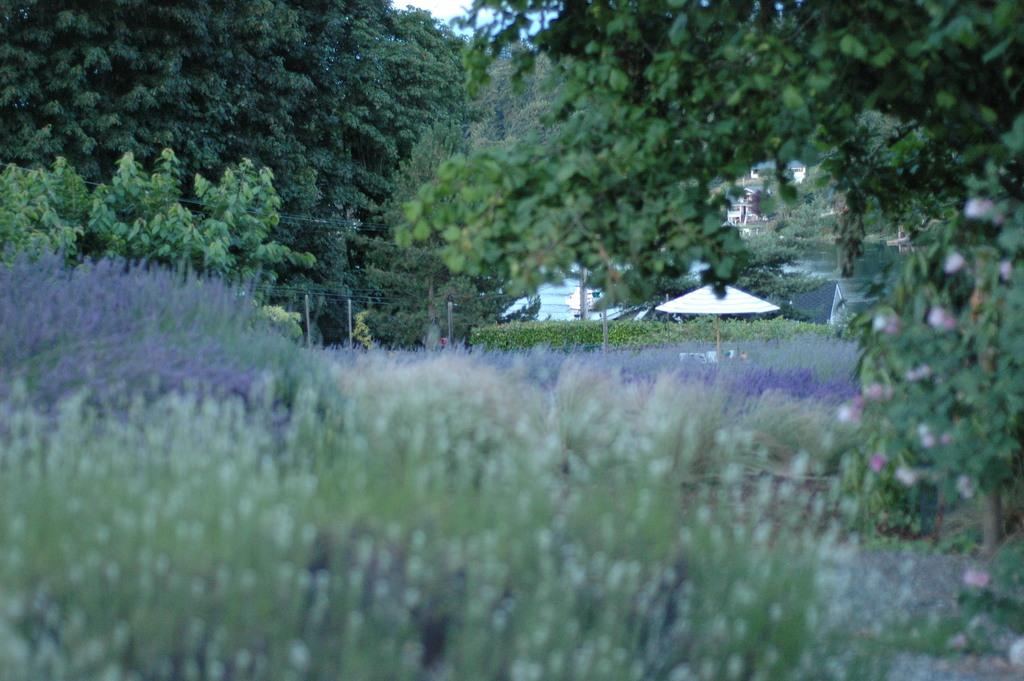What types of vegetation can be seen at the bottom of the image? There are plants at the bottom of the image. What can be seen in the background of the image? There are trees, poles, wires, tents, houses, water, and sky visible in the background of the image. Can you describe the plant with flowers on the right side of the image? There is a plant with flowers on the ground on the right side of the image. How does the plant with flowers maintain its balance in the image? The plant with flowers does not need to maintain its balance in the image; it is stationary on the ground. Can you see any cobwebs in the image? There is no mention of cobwebs in the image, so it cannot be determined if any are present. 